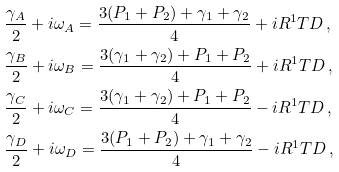Convert formula to latex. <formula><loc_0><loc_0><loc_500><loc_500>& \frac { \gamma _ { A } } { 2 } + i \omega _ { A } = \frac { 3 ( P _ { 1 } + P _ { 2 } ) + \gamma _ { 1 } + \gamma _ { 2 } } { 4 } + i R ^ { 1 } T D \, , \\ & \frac { \gamma _ { B } } { 2 } + i \omega _ { B } = \frac { 3 ( \gamma _ { 1 } + \gamma _ { 2 } ) + P _ { 1 } + P _ { 2 } } { 4 } + i R ^ { 1 } T D \, , \\ & \frac { \gamma _ { C } } { 2 } + i \omega _ { C } = \frac { 3 ( \gamma _ { 1 } + \gamma _ { 2 } ) + P _ { 1 } + P _ { 2 } } { 4 } - i R ^ { 1 } T D \, , \\ & \frac { \gamma _ { D } } { 2 } + i \omega _ { D } = \frac { 3 ( P _ { 1 } + P _ { 2 } ) + \gamma _ { 1 } + \gamma _ { 2 } } { 4 } - i R ^ { 1 } T D \, ,</formula> 